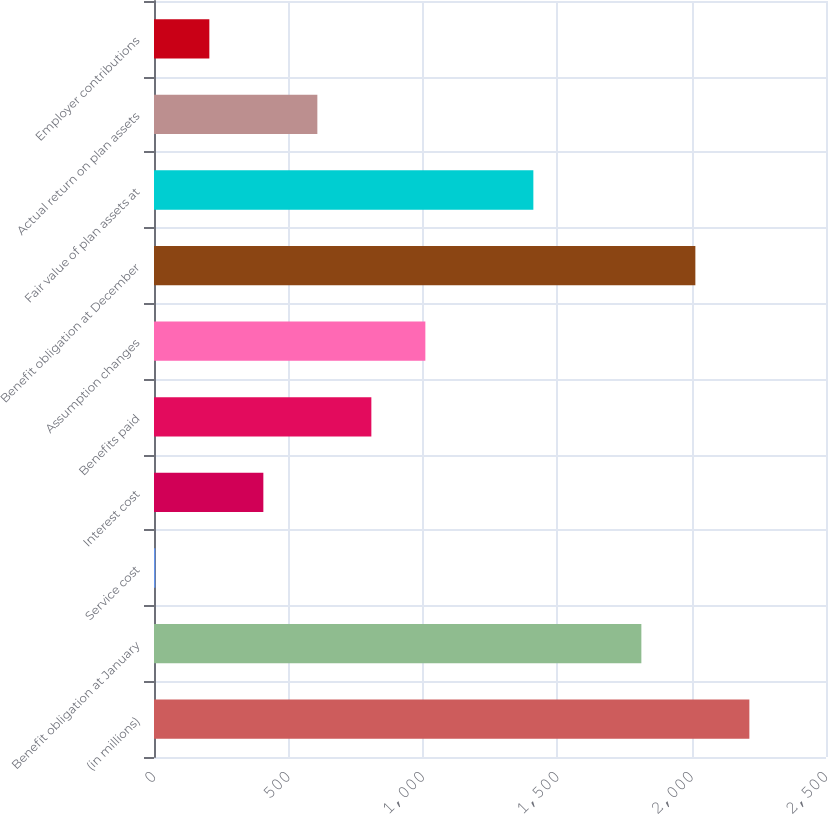Convert chart to OTSL. <chart><loc_0><loc_0><loc_500><loc_500><bar_chart><fcel>(in millions)<fcel>Benefit obligation at January<fcel>Service cost<fcel>Interest cost<fcel>Benefits paid<fcel>Assumption changes<fcel>Benefit obligation at December<fcel>Fair value of plan assets at<fcel>Actual return on plan assets<fcel>Employer contributions<nl><fcel>2214.9<fcel>1813.1<fcel>5<fcel>406.8<fcel>808.6<fcel>1009.5<fcel>2014<fcel>1411.3<fcel>607.7<fcel>205.9<nl></chart> 